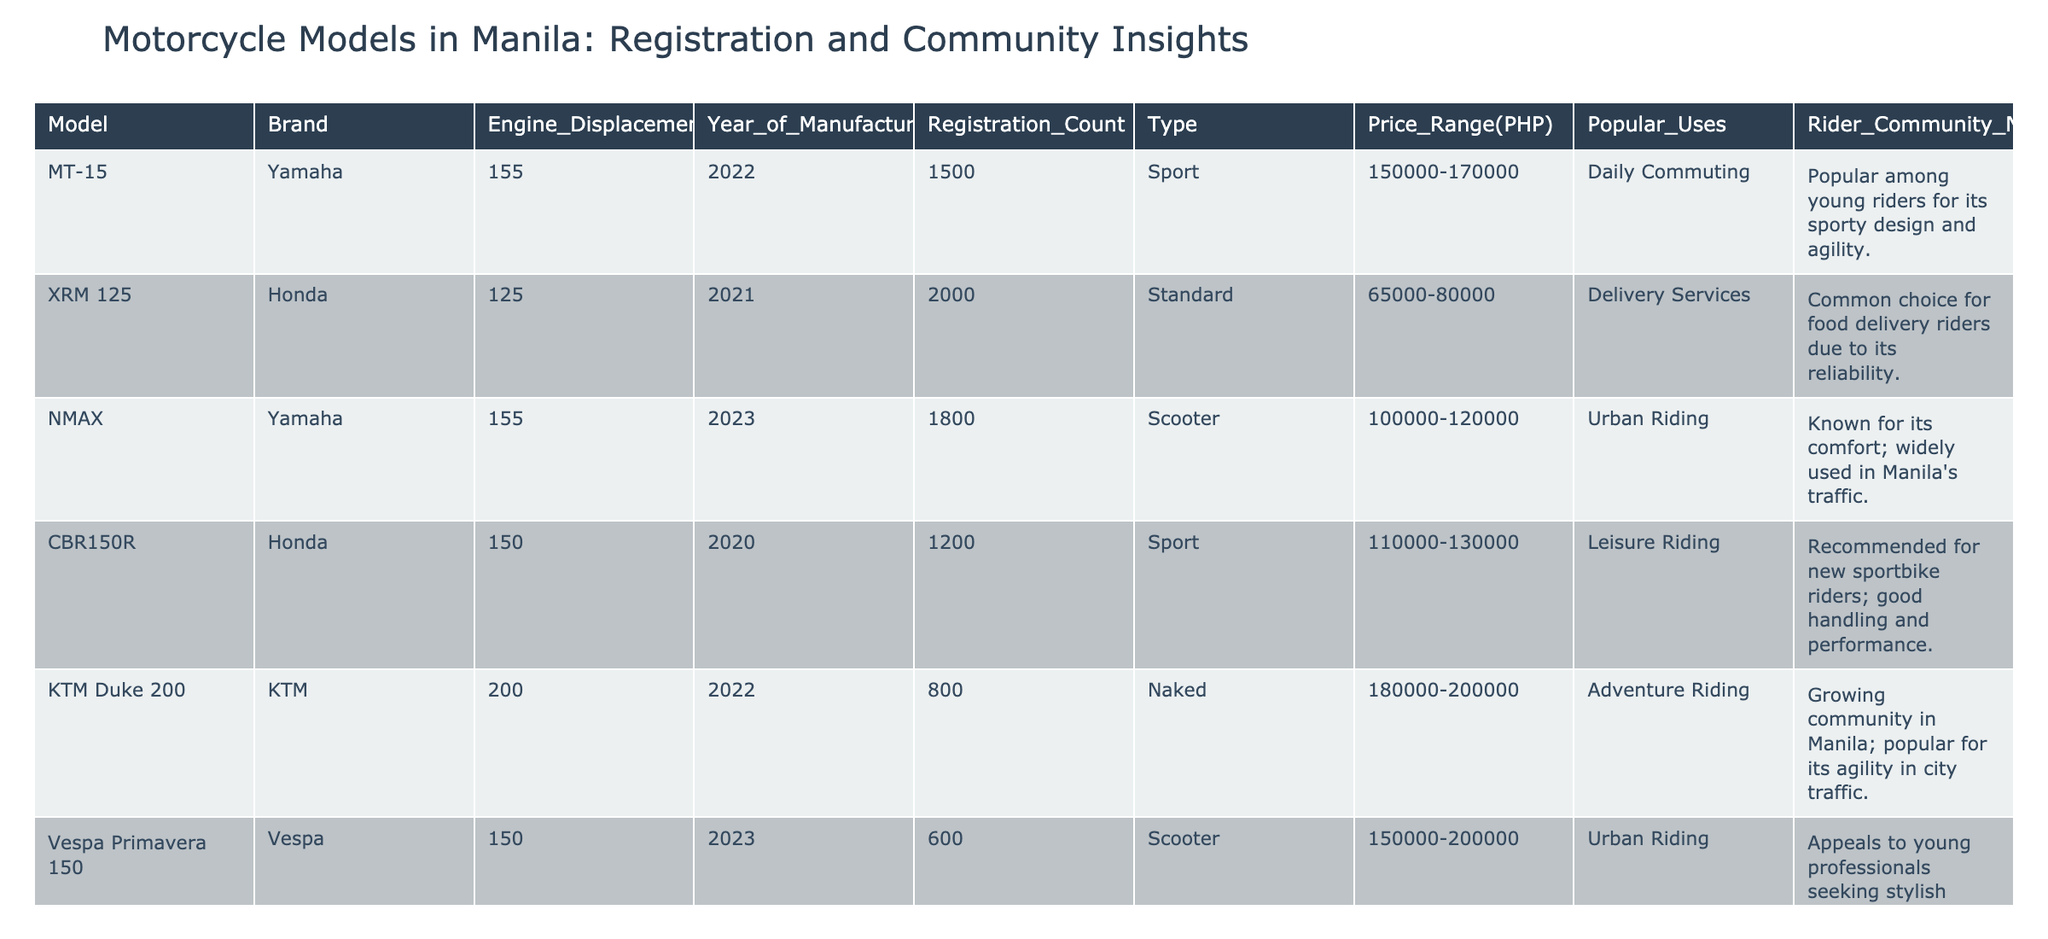What is the most registered motorcycle model in 2023? The 2023 registration data shows two models: NMAX with 1800 registrations and Mio Sporty with 2200 registrations. Comparing them, the Mio Sporty has a higher registration count.
Answer: Mio Sporty Which brand has the highest number of motorcycles registered in 2022? In 2022, Yamaha has one model, the MT-15, with 1500 registrations, while Honda has XRM 125 with 2000. The highest is XRM 125 from Honda.
Answer: Honda How many motorcycles have a registration count of less than 1000? By examining the table, the models with less than 1000 registrations are Kawasaki Z125 Pro (300) and CRF250L (700). Hence, there are two models fitting this criteria.
Answer: 2 What is the price range of the KTM Duke 200? According to the table, the KTM Duke 200 has a price range listed as 180000-200000 PHP. This value is taken directly from the table under the Price Range column.
Answer: 180000-200000 PHP Which motorcycle type has the least number of registrations? Reviewing the registration counts, we see that the Naked type (Kawasaki Z125 Pro with 300) has fewer registrations than any other type in the table.
Answer: Naked What is the average engine displacement of the motorcycles listed? The engine displacements are 155, 125, 155, 150, 200, 150, 155, 250, 115, and 125 CC. The sum of these displacements is 1550 CC. There are 10 models, thus the average is 1550/10 = 155 CC.
Answer: 155 CC Is the XSR155 popular among young riders? The notes for the XSR155 indicate it is popular among hobbyists, not specifically young riders. Hence, the statement is false based on the table's information.
Answer: False Which model is preferred for daily commuting and has the highest registration count? The models preferred for daily commuting are MT-15 (1500 registrations) and Mio Sporty (2200 registrations). Among these, the Mio Sporty has the highest registration count.
Answer: Mio Sporty 